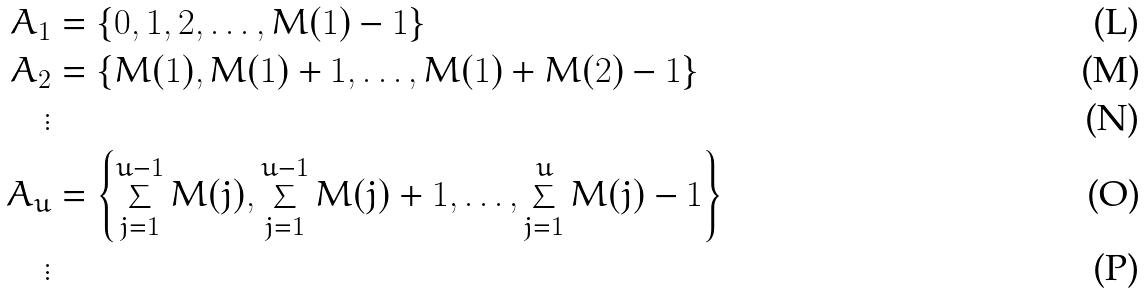Convert formula to latex. <formula><loc_0><loc_0><loc_500><loc_500>A _ { 1 } & = \left \{ 0 , 1 , 2 , \dots , M ( 1 ) - 1 \right \} \\ A _ { 2 } & = \left \{ M ( 1 ) , M ( 1 ) + 1 , \dots , M ( 1 ) + M ( 2 ) - 1 \right \} \\ \vdots \\ A _ { u } & = \left \{ \sum _ { j = 1 } ^ { u - 1 } M ( j ) , \sum _ { j = 1 } ^ { u - 1 } M ( j ) + 1 , \dots , \sum _ { j = 1 } ^ { u } M ( j ) - 1 \right \} \\ \vdots</formula> 